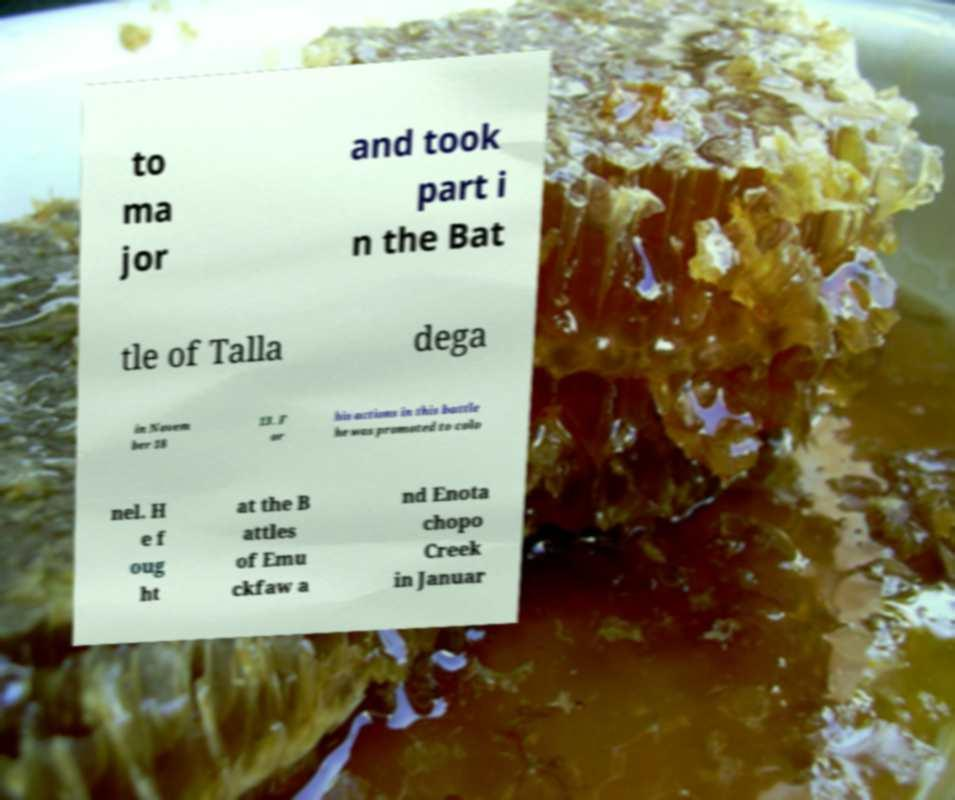Could you extract and type out the text from this image? to ma jor and took part i n the Bat tle of Talla dega in Novem ber 18 13. F or his actions in this battle he was promoted to colo nel. H e f oug ht at the B attles of Emu ckfaw a nd Enota chopo Creek in Januar 